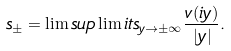Convert formula to latex. <formula><loc_0><loc_0><loc_500><loc_500>\ s _ { \pm } = \lim s u p \lim i t s _ { y \to \pm \infty } \frac { v ( i y ) } { | y | } .</formula> 